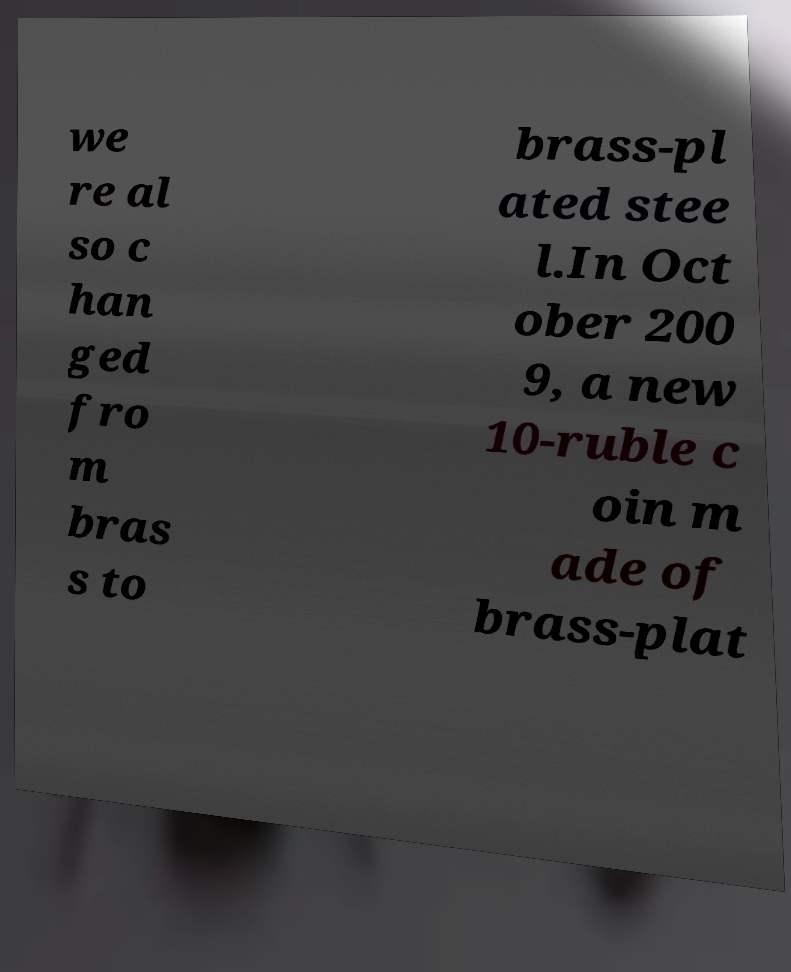There's text embedded in this image that I need extracted. Can you transcribe it verbatim? we re al so c han ged fro m bras s to brass-pl ated stee l.In Oct ober 200 9, a new 10-ruble c oin m ade of brass-plat 